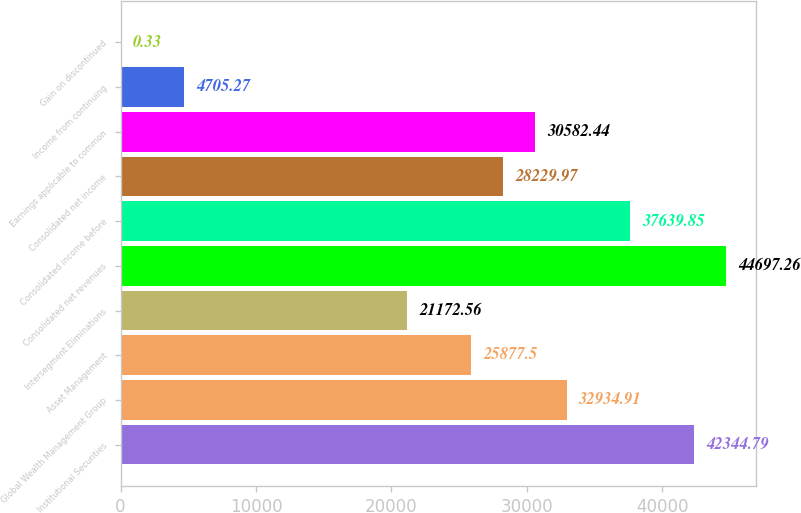<chart> <loc_0><loc_0><loc_500><loc_500><bar_chart><fcel>Institutional Securities<fcel>Global Wealth Management Group<fcel>Asset Management<fcel>Intersegment Eliminations<fcel>Consolidated net revenues<fcel>Consolidated income before<fcel>Consolidated net income<fcel>Earnings applicable to common<fcel>Income from continuing<fcel>Gain on discontinued<nl><fcel>42344.8<fcel>32934.9<fcel>25877.5<fcel>21172.6<fcel>44697.3<fcel>37639.8<fcel>28230<fcel>30582.4<fcel>4705.27<fcel>0.33<nl></chart> 